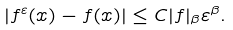<formula> <loc_0><loc_0><loc_500><loc_500>| f ^ { \varepsilon } ( x ) - f ( x ) | \leq C | f | _ { \beta } \varepsilon ^ { \beta } .</formula> 